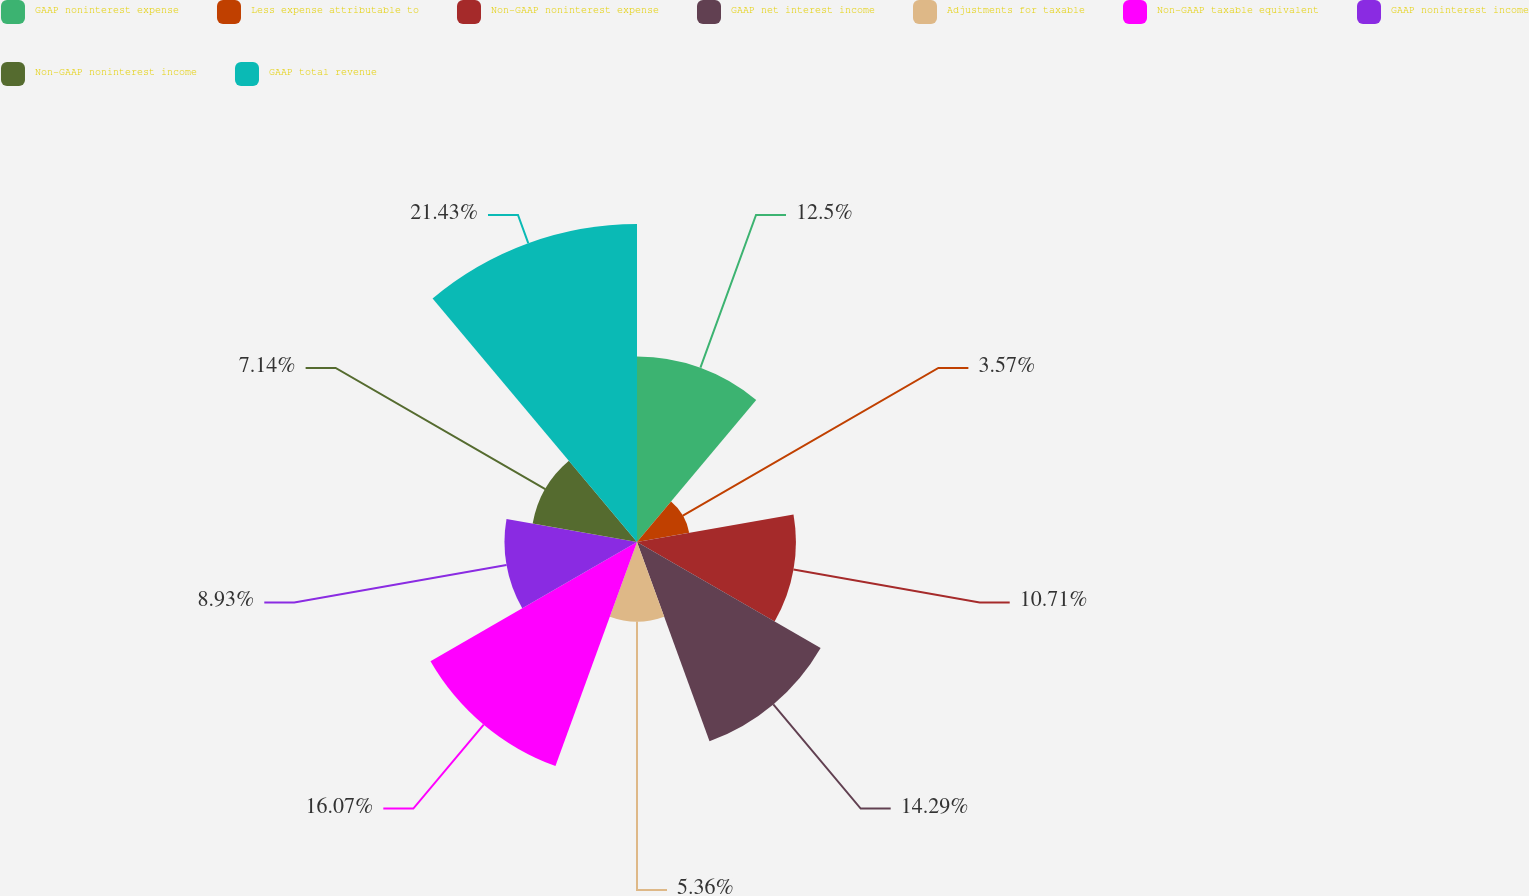<chart> <loc_0><loc_0><loc_500><loc_500><pie_chart><fcel>GAAP noninterest expense<fcel>Less expense attributable to<fcel>Non-GAAP noninterest expense<fcel>GAAP net interest income<fcel>Adjustments for taxable<fcel>Non-GAAP taxable equivalent<fcel>GAAP noninterest income<fcel>Non-GAAP noninterest income<fcel>GAAP total revenue<nl><fcel>12.5%<fcel>3.57%<fcel>10.71%<fcel>14.29%<fcel>5.36%<fcel>16.07%<fcel>8.93%<fcel>7.14%<fcel>21.43%<nl></chart> 